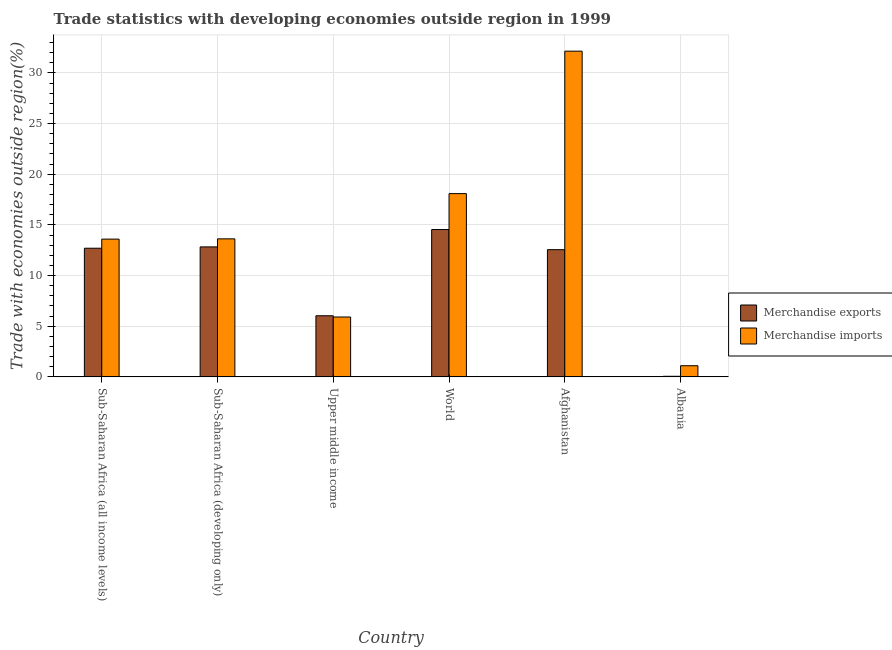How many different coloured bars are there?
Provide a succinct answer. 2. Are the number of bars on each tick of the X-axis equal?
Provide a succinct answer. Yes. How many bars are there on the 6th tick from the left?
Your answer should be very brief. 2. What is the label of the 3rd group of bars from the left?
Give a very brief answer. Upper middle income. In how many cases, is the number of bars for a given country not equal to the number of legend labels?
Your answer should be very brief. 0. What is the merchandise exports in Sub-Saharan Africa (all income levels)?
Give a very brief answer. 12.69. Across all countries, what is the maximum merchandise exports?
Offer a terse response. 14.54. Across all countries, what is the minimum merchandise imports?
Ensure brevity in your answer.  1.1. In which country was the merchandise imports maximum?
Provide a short and direct response. Afghanistan. In which country was the merchandise imports minimum?
Provide a succinct answer. Albania. What is the total merchandise imports in the graph?
Your answer should be very brief. 84.45. What is the difference between the merchandise exports in Afghanistan and that in Upper middle income?
Keep it short and to the point. 6.52. What is the difference between the merchandise imports in Sub-Saharan Africa (developing only) and the merchandise exports in Albania?
Your response must be concise. 13.56. What is the average merchandise exports per country?
Offer a terse response. 9.78. What is the difference between the merchandise imports and merchandise exports in Afghanistan?
Keep it short and to the point. 19.59. In how many countries, is the merchandise exports greater than 22 %?
Provide a succinct answer. 0. What is the ratio of the merchandise exports in Sub-Saharan Africa (all income levels) to that in Sub-Saharan Africa (developing only)?
Offer a terse response. 0.99. Is the difference between the merchandise exports in Sub-Saharan Africa (developing only) and Upper middle income greater than the difference between the merchandise imports in Sub-Saharan Africa (developing only) and Upper middle income?
Ensure brevity in your answer.  No. What is the difference between the highest and the second highest merchandise imports?
Your answer should be compact. 14.06. What is the difference between the highest and the lowest merchandise imports?
Offer a terse response. 31.04. In how many countries, is the merchandise exports greater than the average merchandise exports taken over all countries?
Ensure brevity in your answer.  4. What does the 2nd bar from the right in World represents?
Your answer should be compact. Merchandise exports. How many bars are there?
Ensure brevity in your answer.  12. How many countries are there in the graph?
Provide a succinct answer. 6. Are the values on the major ticks of Y-axis written in scientific E-notation?
Make the answer very short. No. Where does the legend appear in the graph?
Provide a short and direct response. Center right. How are the legend labels stacked?
Ensure brevity in your answer.  Vertical. What is the title of the graph?
Make the answer very short. Trade statistics with developing economies outside region in 1999. Does "Working capital" appear as one of the legend labels in the graph?
Your answer should be compact. No. What is the label or title of the X-axis?
Keep it short and to the point. Country. What is the label or title of the Y-axis?
Ensure brevity in your answer.  Trade with economies outside region(%). What is the Trade with economies outside region(%) in Merchandise exports in Sub-Saharan Africa (all income levels)?
Offer a terse response. 12.69. What is the Trade with economies outside region(%) of Merchandise imports in Sub-Saharan Africa (all income levels)?
Your response must be concise. 13.59. What is the Trade with economies outside region(%) in Merchandise exports in Sub-Saharan Africa (developing only)?
Offer a very short reply. 12.83. What is the Trade with economies outside region(%) of Merchandise imports in Sub-Saharan Africa (developing only)?
Keep it short and to the point. 13.62. What is the Trade with economies outside region(%) of Merchandise exports in Upper middle income?
Keep it short and to the point. 6.03. What is the Trade with economies outside region(%) of Merchandise imports in Upper middle income?
Offer a very short reply. 5.91. What is the Trade with economies outside region(%) of Merchandise exports in World?
Give a very brief answer. 14.54. What is the Trade with economies outside region(%) in Merchandise imports in World?
Your response must be concise. 18.09. What is the Trade with economies outside region(%) in Merchandise exports in Afghanistan?
Keep it short and to the point. 12.55. What is the Trade with economies outside region(%) in Merchandise imports in Afghanistan?
Your answer should be very brief. 32.14. What is the Trade with economies outside region(%) of Merchandise exports in Albania?
Provide a succinct answer. 0.06. What is the Trade with economies outside region(%) of Merchandise imports in Albania?
Offer a very short reply. 1.1. Across all countries, what is the maximum Trade with economies outside region(%) in Merchandise exports?
Make the answer very short. 14.54. Across all countries, what is the maximum Trade with economies outside region(%) of Merchandise imports?
Offer a terse response. 32.14. Across all countries, what is the minimum Trade with economies outside region(%) in Merchandise exports?
Your answer should be compact. 0.06. Across all countries, what is the minimum Trade with economies outside region(%) of Merchandise imports?
Your response must be concise. 1.1. What is the total Trade with economies outside region(%) in Merchandise exports in the graph?
Make the answer very short. 58.7. What is the total Trade with economies outside region(%) in Merchandise imports in the graph?
Provide a succinct answer. 84.45. What is the difference between the Trade with economies outside region(%) of Merchandise exports in Sub-Saharan Africa (all income levels) and that in Sub-Saharan Africa (developing only)?
Ensure brevity in your answer.  -0.13. What is the difference between the Trade with economies outside region(%) in Merchandise imports in Sub-Saharan Africa (all income levels) and that in Sub-Saharan Africa (developing only)?
Ensure brevity in your answer.  -0.03. What is the difference between the Trade with economies outside region(%) in Merchandise exports in Sub-Saharan Africa (all income levels) and that in Upper middle income?
Provide a short and direct response. 6.66. What is the difference between the Trade with economies outside region(%) in Merchandise imports in Sub-Saharan Africa (all income levels) and that in Upper middle income?
Keep it short and to the point. 7.69. What is the difference between the Trade with economies outside region(%) of Merchandise exports in Sub-Saharan Africa (all income levels) and that in World?
Your response must be concise. -1.85. What is the difference between the Trade with economies outside region(%) of Merchandise imports in Sub-Saharan Africa (all income levels) and that in World?
Your answer should be very brief. -4.49. What is the difference between the Trade with economies outside region(%) of Merchandise exports in Sub-Saharan Africa (all income levels) and that in Afghanistan?
Ensure brevity in your answer.  0.14. What is the difference between the Trade with economies outside region(%) of Merchandise imports in Sub-Saharan Africa (all income levels) and that in Afghanistan?
Offer a terse response. -18.55. What is the difference between the Trade with economies outside region(%) in Merchandise exports in Sub-Saharan Africa (all income levels) and that in Albania?
Offer a very short reply. 12.64. What is the difference between the Trade with economies outside region(%) of Merchandise imports in Sub-Saharan Africa (all income levels) and that in Albania?
Your response must be concise. 12.5. What is the difference between the Trade with economies outside region(%) of Merchandise exports in Sub-Saharan Africa (developing only) and that in Upper middle income?
Give a very brief answer. 6.8. What is the difference between the Trade with economies outside region(%) of Merchandise imports in Sub-Saharan Africa (developing only) and that in Upper middle income?
Make the answer very short. 7.71. What is the difference between the Trade with economies outside region(%) in Merchandise exports in Sub-Saharan Africa (developing only) and that in World?
Offer a very short reply. -1.71. What is the difference between the Trade with economies outside region(%) in Merchandise imports in Sub-Saharan Africa (developing only) and that in World?
Keep it short and to the point. -4.47. What is the difference between the Trade with economies outside region(%) of Merchandise exports in Sub-Saharan Africa (developing only) and that in Afghanistan?
Offer a terse response. 0.27. What is the difference between the Trade with economies outside region(%) in Merchandise imports in Sub-Saharan Africa (developing only) and that in Afghanistan?
Ensure brevity in your answer.  -18.52. What is the difference between the Trade with economies outside region(%) in Merchandise exports in Sub-Saharan Africa (developing only) and that in Albania?
Provide a short and direct response. 12.77. What is the difference between the Trade with economies outside region(%) in Merchandise imports in Sub-Saharan Africa (developing only) and that in Albania?
Offer a very short reply. 12.52. What is the difference between the Trade with economies outside region(%) in Merchandise exports in Upper middle income and that in World?
Give a very brief answer. -8.51. What is the difference between the Trade with economies outside region(%) of Merchandise imports in Upper middle income and that in World?
Give a very brief answer. -12.18. What is the difference between the Trade with economies outside region(%) in Merchandise exports in Upper middle income and that in Afghanistan?
Make the answer very short. -6.52. What is the difference between the Trade with economies outside region(%) of Merchandise imports in Upper middle income and that in Afghanistan?
Your answer should be very brief. -26.23. What is the difference between the Trade with economies outside region(%) of Merchandise exports in Upper middle income and that in Albania?
Make the answer very short. 5.97. What is the difference between the Trade with economies outside region(%) of Merchandise imports in Upper middle income and that in Albania?
Your answer should be compact. 4.81. What is the difference between the Trade with economies outside region(%) in Merchandise exports in World and that in Afghanistan?
Your answer should be compact. 1.99. What is the difference between the Trade with economies outside region(%) in Merchandise imports in World and that in Afghanistan?
Your response must be concise. -14.06. What is the difference between the Trade with economies outside region(%) of Merchandise exports in World and that in Albania?
Your response must be concise. 14.48. What is the difference between the Trade with economies outside region(%) in Merchandise imports in World and that in Albania?
Provide a short and direct response. 16.99. What is the difference between the Trade with economies outside region(%) in Merchandise exports in Afghanistan and that in Albania?
Make the answer very short. 12.49. What is the difference between the Trade with economies outside region(%) of Merchandise imports in Afghanistan and that in Albania?
Provide a succinct answer. 31.04. What is the difference between the Trade with economies outside region(%) of Merchandise exports in Sub-Saharan Africa (all income levels) and the Trade with economies outside region(%) of Merchandise imports in Sub-Saharan Africa (developing only)?
Offer a terse response. -0.93. What is the difference between the Trade with economies outside region(%) of Merchandise exports in Sub-Saharan Africa (all income levels) and the Trade with economies outside region(%) of Merchandise imports in Upper middle income?
Give a very brief answer. 6.79. What is the difference between the Trade with economies outside region(%) of Merchandise exports in Sub-Saharan Africa (all income levels) and the Trade with economies outside region(%) of Merchandise imports in World?
Offer a very short reply. -5.39. What is the difference between the Trade with economies outside region(%) in Merchandise exports in Sub-Saharan Africa (all income levels) and the Trade with economies outside region(%) in Merchandise imports in Afghanistan?
Ensure brevity in your answer.  -19.45. What is the difference between the Trade with economies outside region(%) in Merchandise exports in Sub-Saharan Africa (all income levels) and the Trade with economies outside region(%) in Merchandise imports in Albania?
Your response must be concise. 11.6. What is the difference between the Trade with economies outside region(%) of Merchandise exports in Sub-Saharan Africa (developing only) and the Trade with economies outside region(%) of Merchandise imports in Upper middle income?
Give a very brief answer. 6.92. What is the difference between the Trade with economies outside region(%) in Merchandise exports in Sub-Saharan Africa (developing only) and the Trade with economies outside region(%) in Merchandise imports in World?
Keep it short and to the point. -5.26. What is the difference between the Trade with economies outside region(%) in Merchandise exports in Sub-Saharan Africa (developing only) and the Trade with economies outside region(%) in Merchandise imports in Afghanistan?
Provide a succinct answer. -19.32. What is the difference between the Trade with economies outside region(%) of Merchandise exports in Sub-Saharan Africa (developing only) and the Trade with economies outside region(%) of Merchandise imports in Albania?
Make the answer very short. 11.73. What is the difference between the Trade with economies outside region(%) in Merchandise exports in Upper middle income and the Trade with economies outside region(%) in Merchandise imports in World?
Ensure brevity in your answer.  -12.05. What is the difference between the Trade with economies outside region(%) of Merchandise exports in Upper middle income and the Trade with economies outside region(%) of Merchandise imports in Afghanistan?
Provide a short and direct response. -26.11. What is the difference between the Trade with economies outside region(%) of Merchandise exports in Upper middle income and the Trade with economies outside region(%) of Merchandise imports in Albania?
Provide a succinct answer. 4.93. What is the difference between the Trade with economies outside region(%) of Merchandise exports in World and the Trade with economies outside region(%) of Merchandise imports in Afghanistan?
Provide a succinct answer. -17.6. What is the difference between the Trade with economies outside region(%) in Merchandise exports in World and the Trade with economies outside region(%) in Merchandise imports in Albania?
Ensure brevity in your answer.  13.44. What is the difference between the Trade with economies outside region(%) of Merchandise exports in Afghanistan and the Trade with economies outside region(%) of Merchandise imports in Albania?
Give a very brief answer. 11.45. What is the average Trade with economies outside region(%) of Merchandise exports per country?
Make the answer very short. 9.78. What is the average Trade with economies outside region(%) in Merchandise imports per country?
Give a very brief answer. 14.08. What is the difference between the Trade with economies outside region(%) in Merchandise exports and Trade with economies outside region(%) in Merchandise imports in Sub-Saharan Africa (all income levels)?
Provide a short and direct response. -0.9. What is the difference between the Trade with economies outside region(%) in Merchandise exports and Trade with economies outside region(%) in Merchandise imports in Sub-Saharan Africa (developing only)?
Give a very brief answer. -0.79. What is the difference between the Trade with economies outside region(%) in Merchandise exports and Trade with economies outside region(%) in Merchandise imports in Upper middle income?
Make the answer very short. 0.12. What is the difference between the Trade with economies outside region(%) in Merchandise exports and Trade with economies outside region(%) in Merchandise imports in World?
Offer a very short reply. -3.54. What is the difference between the Trade with economies outside region(%) of Merchandise exports and Trade with economies outside region(%) of Merchandise imports in Afghanistan?
Your answer should be very brief. -19.59. What is the difference between the Trade with economies outside region(%) in Merchandise exports and Trade with economies outside region(%) in Merchandise imports in Albania?
Offer a very short reply. -1.04. What is the ratio of the Trade with economies outside region(%) in Merchandise exports in Sub-Saharan Africa (all income levels) to that in Sub-Saharan Africa (developing only)?
Make the answer very short. 0.99. What is the ratio of the Trade with economies outside region(%) of Merchandise imports in Sub-Saharan Africa (all income levels) to that in Sub-Saharan Africa (developing only)?
Provide a short and direct response. 1. What is the ratio of the Trade with economies outside region(%) in Merchandise exports in Sub-Saharan Africa (all income levels) to that in Upper middle income?
Offer a very short reply. 2.11. What is the ratio of the Trade with economies outside region(%) of Merchandise imports in Sub-Saharan Africa (all income levels) to that in Upper middle income?
Your answer should be compact. 2.3. What is the ratio of the Trade with economies outside region(%) of Merchandise exports in Sub-Saharan Africa (all income levels) to that in World?
Your response must be concise. 0.87. What is the ratio of the Trade with economies outside region(%) in Merchandise imports in Sub-Saharan Africa (all income levels) to that in World?
Offer a terse response. 0.75. What is the ratio of the Trade with economies outside region(%) of Merchandise exports in Sub-Saharan Africa (all income levels) to that in Afghanistan?
Your response must be concise. 1.01. What is the ratio of the Trade with economies outside region(%) of Merchandise imports in Sub-Saharan Africa (all income levels) to that in Afghanistan?
Offer a terse response. 0.42. What is the ratio of the Trade with economies outside region(%) in Merchandise exports in Sub-Saharan Africa (all income levels) to that in Albania?
Make the answer very short. 218.77. What is the ratio of the Trade with economies outside region(%) of Merchandise imports in Sub-Saharan Africa (all income levels) to that in Albania?
Your answer should be very brief. 12.37. What is the ratio of the Trade with economies outside region(%) in Merchandise exports in Sub-Saharan Africa (developing only) to that in Upper middle income?
Your response must be concise. 2.13. What is the ratio of the Trade with economies outside region(%) of Merchandise imports in Sub-Saharan Africa (developing only) to that in Upper middle income?
Your answer should be very brief. 2.31. What is the ratio of the Trade with economies outside region(%) of Merchandise exports in Sub-Saharan Africa (developing only) to that in World?
Your answer should be very brief. 0.88. What is the ratio of the Trade with economies outside region(%) of Merchandise imports in Sub-Saharan Africa (developing only) to that in World?
Give a very brief answer. 0.75. What is the ratio of the Trade with economies outside region(%) in Merchandise exports in Sub-Saharan Africa (developing only) to that in Afghanistan?
Your answer should be compact. 1.02. What is the ratio of the Trade with economies outside region(%) of Merchandise imports in Sub-Saharan Africa (developing only) to that in Afghanistan?
Provide a short and direct response. 0.42. What is the ratio of the Trade with economies outside region(%) of Merchandise exports in Sub-Saharan Africa (developing only) to that in Albania?
Offer a very short reply. 221.05. What is the ratio of the Trade with economies outside region(%) of Merchandise imports in Sub-Saharan Africa (developing only) to that in Albania?
Offer a terse response. 12.39. What is the ratio of the Trade with economies outside region(%) in Merchandise exports in Upper middle income to that in World?
Your answer should be very brief. 0.41. What is the ratio of the Trade with economies outside region(%) of Merchandise imports in Upper middle income to that in World?
Keep it short and to the point. 0.33. What is the ratio of the Trade with economies outside region(%) of Merchandise exports in Upper middle income to that in Afghanistan?
Offer a very short reply. 0.48. What is the ratio of the Trade with economies outside region(%) of Merchandise imports in Upper middle income to that in Afghanistan?
Offer a terse response. 0.18. What is the ratio of the Trade with economies outside region(%) of Merchandise exports in Upper middle income to that in Albania?
Provide a succinct answer. 103.92. What is the ratio of the Trade with economies outside region(%) of Merchandise imports in Upper middle income to that in Albania?
Make the answer very short. 5.37. What is the ratio of the Trade with economies outside region(%) of Merchandise exports in World to that in Afghanistan?
Your answer should be compact. 1.16. What is the ratio of the Trade with economies outside region(%) of Merchandise imports in World to that in Afghanistan?
Your response must be concise. 0.56. What is the ratio of the Trade with economies outside region(%) in Merchandise exports in World to that in Albania?
Your answer should be very brief. 250.59. What is the ratio of the Trade with economies outside region(%) of Merchandise imports in World to that in Albania?
Your answer should be very brief. 16.45. What is the ratio of the Trade with economies outside region(%) in Merchandise exports in Afghanistan to that in Albania?
Your response must be concise. 216.33. What is the ratio of the Trade with economies outside region(%) in Merchandise imports in Afghanistan to that in Albania?
Ensure brevity in your answer.  29.24. What is the difference between the highest and the second highest Trade with economies outside region(%) in Merchandise exports?
Ensure brevity in your answer.  1.71. What is the difference between the highest and the second highest Trade with economies outside region(%) in Merchandise imports?
Ensure brevity in your answer.  14.06. What is the difference between the highest and the lowest Trade with economies outside region(%) in Merchandise exports?
Provide a succinct answer. 14.48. What is the difference between the highest and the lowest Trade with economies outside region(%) in Merchandise imports?
Offer a terse response. 31.04. 